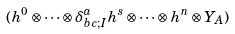Convert formula to latex. <formula><loc_0><loc_0><loc_500><loc_500>( h ^ { 0 } \otimes \cdots \otimes \delta _ { b c ; I } ^ { a } h ^ { s } \otimes \cdots \otimes h ^ { n } \otimes Y _ { A } )</formula> 